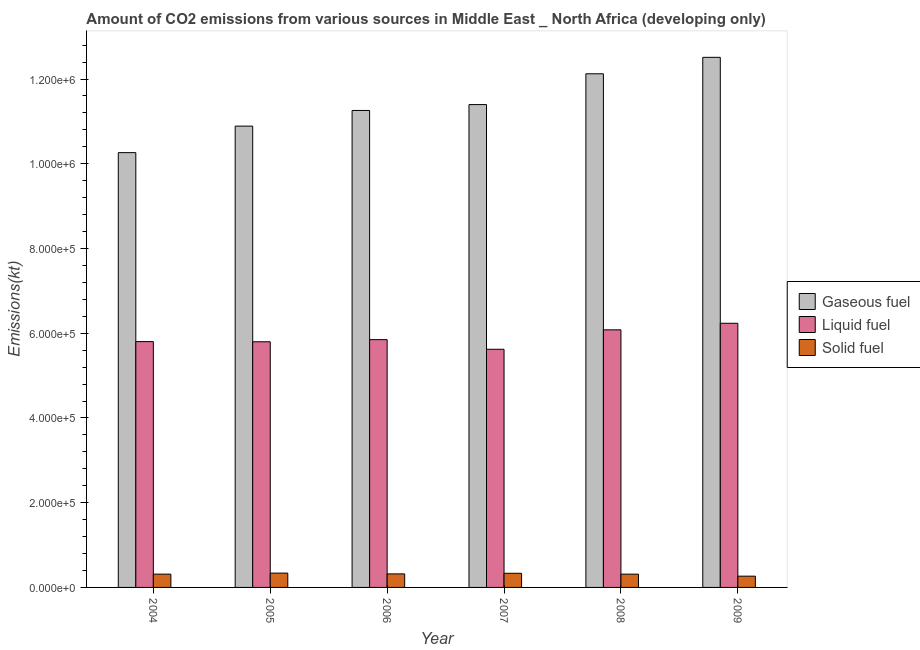How many groups of bars are there?
Provide a succinct answer. 6. Are the number of bars on each tick of the X-axis equal?
Your answer should be compact. Yes. How many bars are there on the 3rd tick from the left?
Ensure brevity in your answer.  3. How many bars are there on the 1st tick from the right?
Provide a short and direct response. 3. What is the label of the 5th group of bars from the left?
Your response must be concise. 2008. What is the amount of co2 emissions from solid fuel in 2009?
Give a very brief answer. 2.66e+04. Across all years, what is the maximum amount of co2 emissions from liquid fuel?
Provide a succinct answer. 6.24e+05. Across all years, what is the minimum amount of co2 emissions from gaseous fuel?
Provide a succinct answer. 1.03e+06. What is the total amount of co2 emissions from solid fuel in the graph?
Provide a short and direct response. 1.88e+05. What is the difference between the amount of co2 emissions from solid fuel in 2004 and that in 2006?
Offer a very short reply. -561.59. What is the difference between the amount of co2 emissions from solid fuel in 2008 and the amount of co2 emissions from liquid fuel in 2005?
Ensure brevity in your answer.  -2484.98. What is the average amount of co2 emissions from liquid fuel per year?
Make the answer very short. 5.90e+05. What is the ratio of the amount of co2 emissions from solid fuel in 2004 to that in 2009?
Offer a terse response. 1.18. Is the difference between the amount of co2 emissions from gaseous fuel in 2004 and 2006 greater than the difference between the amount of co2 emissions from solid fuel in 2004 and 2006?
Give a very brief answer. No. What is the difference between the highest and the second highest amount of co2 emissions from liquid fuel?
Your answer should be very brief. 1.55e+04. What is the difference between the highest and the lowest amount of co2 emissions from gaseous fuel?
Keep it short and to the point. 2.25e+05. In how many years, is the amount of co2 emissions from liquid fuel greater than the average amount of co2 emissions from liquid fuel taken over all years?
Your answer should be very brief. 2. What does the 2nd bar from the left in 2009 represents?
Your answer should be compact. Liquid fuel. What does the 3rd bar from the right in 2006 represents?
Keep it short and to the point. Gaseous fuel. How many bars are there?
Provide a succinct answer. 18. What is the difference between two consecutive major ticks on the Y-axis?
Your response must be concise. 2.00e+05. Does the graph contain any zero values?
Ensure brevity in your answer.  No. Does the graph contain grids?
Keep it short and to the point. No. Where does the legend appear in the graph?
Your response must be concise. Center right. What is the title of the graph?
Give a very brief answer. Amount of CO2 emissions from various sources in Middle East _ North Africa (developing only). Does "Domestic economy" appear as one of the legend labels in the graph?
Your answer should be compact. No. What is the label or title of the X-axis?
Provide a short and direct response. Year. What is the label or title of the Y-axis?
Offer a terse response. Emissions(kt). What is the Emissions(kt) in Gaseous fuel in 2004?
Your response must be concise. 1.03e+06. What is the Emissions(kt) of Liquid fuel in 2004?
Offer a very short reply. 5.80e+05. What is the Emissions(kt) of Solid fuel in 2004?
Offer a terse response. 3.14e+04. What is the Emissions(kt) in Gaseous fuel in 2005?
Your response must be concise. 1.09e+06. What is the Emissions(kt) in Liquid fuel in 2005?
Your response must be concise. 5.80e+05. What is the Emissions(kt) of Solid fuel in 2005?
Offer a terse response. 3.38e+04. What is the Emissions(kt) of Gaseous fuel in 2006?
Provide a succinct answer. 1.13e+06. What is the Emissions(kt) of Liquid fuel in 2006?
Offer a terse response. 5.85e+05. What is the Emissions(kt) in Solid fuel in 2006?
Provide a short and direct response. 3.19e+04. What is the Emissions(kt) in Gaseous fuel in 2007?
Your response must be concise. 1.14e+06. What is the Emissions(kt) of Liquid fuel in 2007?
Ensure brevity in your answer.  5.62e+05. What is the Emissions(kt) of Solid fuel in 2007?
Make the answer very short. 3.34e+04. What is the Emissions(kt) in Gaseous fuel in 2008?
Give a very brief answer. 1.21e+06. What is the Emissions(kt) of Liquid fuel in 2008?
Your answer should be very brief. 6.08e+05. What is the Emissions(kt) in Solid fuel in 2008?
Give a very brief answer. 3.13e+04. What is the Emissions(kt) in Gaseous fuel in 2009?
Offer a terse response. 1.25e+06. What is the Emissions(kt) of Liquid fuel in 2009?
Your answer should be very brief. 6.24e+05. What is the Emissions(kt) of Solid fuel in 2009?
Keep it short and to the point. 2.66e+04. Across all years, what is the maximum Emissions(kt) in Gaseous fuel?
Your answer should be very brief. 1.25e+06. Across all years, what is the maximum Emissions(kt) of Liquid fuel?
Offer a very short reply. 6.24e+05. Across all years, what is the maximum Emissions(kt) of Solid fuel?
Make the answer very short. 3.38e+04. Across all years, what is the minimum Emissions(kt) in Gaseous fuel?
Your answer should be compact. 1.03e+06. Across all years, what is the minimum Emissions(kt) of Liquid fuel?
Your response must be concise. 5.62e+05. Across all years, what is the minimum Emissions(kt) in Solid fuel?
Provide a short and direct response. 2.66e+04. What is the total Emissions(kt) in Gaseous fuel in the graph?
Provide a short and direct response. 6.84e+06. What is the total Emissions(kt) in Liquid fuel in the graph?
Provide a short and direct response. 3.54e+06. What is the total Emissions(kt) of Solid fuel in the graph?
Make the answer very short. 1.88e+05. What is the difference between the Emissions(kt) of Gaseous fuel in 2004 and that in 2005?
Provide a succinct answer. -6.26e+04. What is the difference between the Emissions(kt) of Liquid fuel in 2004 and that in 2005?
Offer a very short reply. 418.04. What is the difference between the Emissions(kt) in Solid fuel in 2004 and that in 2005?
Offer a very short reply. -2440.98. What is the difference between the Emissions(kt) in Gaseous fuel in 2004 and that in 2006?
Keep it short and to the point. -9.95e+04. What is the difference between the Emissions(kt) in Liquid fuel in 2004 and that in 2006?
Make the answer very short. -4649.76. What is the difference between the Emissions(kt) of Solid fuel in 2004 and that in 2006?
Offer a terse response. -561.59. What is the difference between the Emissions(kt) of Gaseous fuel in 2004 and that in 2007?
Make the answer very short. -1.13e+05. What is the difference between the Emissions(kt) in Liquid fuel in 2004 and that in 2007?
Ensure brevity in your answer.  1.81e+04. What is the difference between the Emissions(kt) of Solid fuel in 2004 and that in 2007?
Your response must be concise. -1997.69. What is the difference between the Emissions(kt) in Gaseous fuel in 2004 and that in 2008?
Keep it short and to the point. -1.86e+05. What is the difference between the Emissions(kt) of Liquid fuel in 2004 and that in 2008?
Keep it short and to the point. -2.78e+04. What is the difference between the Emissions(kt) of Solid fuel in 2004 and that in 2008?
Make the answer very short. 44. What is the difference between the Emissions(kt) of Gaseous fuel in 2004 and that in 2009?
Your answer should be compact. -2.25e+05. What is the difference between the Emissions(kt) of Liquid fuel in 2004 and that in 2009?
Make the answer very short. -4.33e+04. What is the difference between the Emissions(kt) of Solid fuel in 2004 and that in 2009?
Offer a very short reply. 4789.2. What is the difference between the Emissions(kt) of Gaseous fuel in 2005 and that in 2006?
Offer a terse response. -3.69e+04. What is the difference between the Emissions(kt) of Liquid fuel in 2005 and that in 2006?
Ensure brevity in your answer.  -5067.79. What is the difference between the Emissions(kt) in Solid fuel in 2005 and that in 2006?
Keep it short and to the point. 1879.4. What is the difference between the Emissions(kt) of Gaseous fuel in 2005 and that in 2007?
Your answer should be compact. -5.08e+04. What is the difference between the Emissions(kt) in Liquid fuel in 2005 and that in 2007?
Make the answer very short. 1.77e+04. What is the difference between the Emissions(kt) of Solid fuel in 2005 and that in 2007?
Make the answer very short. 443.29. What is the difference between the Emissions(kt) of Gaseous fuel in 2005 and that in 2008?
Provide a succinct answer. -1.24e+05. What is the difference between the Emissions(kt) in Liquid fuel in 2005 and that in 2008?
Your answer should be very brief. -2.82e+04. What is the difference between the Emissions(kt) in Solid fuel in 2005 and that in 2008?
Your response must be concise. 2484.98. What is the difference between the Emissions(kt) in Gaseous fuel in 2005 and that in 2009?
Provide a succinct answer. -1.62e+05. What is the difference between the Emissions(kt) in Liquid fuel in 2005 and that in 2009?
Give a very brief answer. -4.37e+04. What is the difference between the Emissions(kt) in Solid fuel in 2005 and that in 2009?
Give a very brief answer. 7230.18. What is the difference between the Emissions(kt) of Gaseous fuel in 2006 and that in 2007?
Keep it short and to the point. -1.39e+04. What is the difference between the Emissions(kt) of Liquid fuel in 2006 and that in 2007?
Provide a succinct answer. 2.28e+04. What is the difference between the Emissions(kt) in Solid fuel in 2006 and that in 2007?
Offer a very short reply. -1436.1. What is the difference between the Emissions(kt) of Gaseous fuel in 2006 and that in 2008?
Keep it short and to the point. -8.66e+04. What is the difference between the Emissions(kt) of Liquid fuel in 2006 and that in 2008?
Offer a very short reply. -2.31e+04. What is the difference between the Emissions(kt) in Solid fuel in 2006 and that in 2008?
Your answer should be very brief. 605.59. What is the difference between the Emissions(kt) of Gaseous fuel in 2006 and that in 2009?
Your answer should be very brief. -1.25e+05. What is the difference between the Emissions(kt) in Liquid fuel in 2006 and that in 2009?
Keep it short and to the point. -3.86e+04. What is the difference between the Emissions(kt) in Solid fuel in 2006 and that in 2009?
Your answer should be compact. 5350.78. What is the difference between the Emissions(kt) in Gaseous fuel in 2007 and that in 2008?
Keep it short and to the point. -7.27e+04. What is the difference between the Emissions(kt) of Liquid fuel in 2007 and that in 2008?
Give a very brief answer. -4.59e+04. What is the difference between the Emissions(kt) of Solid fuel in 2007 and that in 2008?
Give a very brief answer. 2041.69. What is the difference between the Emissions(kt) of Gaseous fuel in 2007 and that in 2009?
Offer a very short reply. -1.12e+05. What is the difference between the Emissions(kt) of Liquid fuel in 2007 and that in 2009?
Provide a succinct answer. -6.14e+04. What is the difference between the Emissions(kt) in Solid fuel in 2007 and that in 2009?
Provide a short and direct response. 6786.89. What is the difference between the Emissions(kt) of Gaseous fuel in 2008 and that in 2009?
Provide a succinct answer. -3.88e+04. What is the difference between the Emissions(kt) of Liquid fuel in 2008 and that in 2009?
Your response must be concise. -1.55e+04. What is the difference between the Emissions(kt) in Solid fuel in 2008 and that in 2009?
Ensure brevity in your answer.  4745.2. What is the difference between the Emissions(kt) of Gaseous fuel in 2004 and the Emissions(kt) of Liquid fuel in 2005?
Your response must be concise. 4.46e+05. What is the difference between the Emissions(kt) in Gaseous fuel in 2004 and the Emissions(kt) in Solid fuel in 2005?
Offer a terse response. 9.92e+05. What is the difference between the Emissions(kt) in Liquid fuel in 2004 and the Emissions(kt) in Solid fuel in 2005?
Make the answer very short. 5.46e+05. What is the difference between the Emissions(kt) of Gaseous fuel in 2004 and the Emissions(kt) of Liquid fuel in 2006?
Give a very brief answer. 4.41e+05. What is the difference between the Emissions(kt) of Gaseous fuel in 2004 and the Emissions(kt) of Solid fuel in 2006?
Offer a very short reply. 9.94e+05. What is the difference between the Emissions(kt) of Liquid fuel in 2004 and the Emissions(kt) of Solid fuel in 2006?
Your response must be concise. 5.48e+05. What is the difference between the Emissions(kt) of Gaseous fuel in 2004 and the Emissions(kt) of Liquid fuel in 2007?
Keep it short and to the point. 4.64e+05. What is the difference between the Emissions(kt) in Gaseous fuel in 2004 and the Emissions(kt) in Solid fuel in 2007?
Ensure brevity in your answer.  9.93e+05. What is the difference between the Emissions(kt) of Liquid fuel in 2004 and the Emissions(kt) of Solid fuel in 2007?
Your answer should be compact. 5.47e+05. What is the difference between the Emissions(kt) in Gaseous fuel in 2004 and the Emissions(kt) in Liquid fuel in 2008?
Provide a short and direct response. 4.18e+05. What is the difference between the Emissions(kt) of Gaseous fuel in 2004 and the Emissions(kt) of Solid fuel in 2008?
Ensure brevity in your answer.  9.95e+05. What is the difference between the Emissions(kt) of Liquid fuel in 2004 and the Emissions(kt) of Solid fuel in 2008?
Your answer should be very brief. 5.49e+05. What is the difference between the Emissions(kt) of Gaseous fuel in 2004 and the Emissions(kt) of Liquid fuel in 2009?
Provide a succinct answer. 4.03e+05. What is the difference between the Emissions(kt) in Gaseous fuel in 2004 and the Emissions(kt) in Solid fuel in 2009?
Make the answer very short. 1.00e+06. What is the difference between the Emissions(kt) of Liquid fuel in 2004 and the Emissions(kt) of Solid fuel in 2009?
Your answer should be very brief. 5.54e+05. What is the difference between the Emissions(kt) in Gaseous fuel in 2005 and the Emissions(kt) in Liquid fuel in 2006?
Give a very brief answer. 5.04e+05. What is the difference between the Emissions(kt) of Gaseous fuel in 2005 and the Emissions(kt) of Solid fuel in 2006?
Your answer should be compact. 1.06e+06. What is the difference between the Emissions(kt) of Liquid fuel in 2005 and the Emissions(kt) of Solid fuel in 2006?
Provide a short and direct response. 5.48e+05. What is the difference between the Emissions(kt) in Gaseous fuel in 2005 and the Emissions(kt) in Liquid fuel in 2007?
Your answer should be compact. 5.27e+05. What is the difference between the Emissions(kt) of Gaseous fuel in 2005 and the Emissions(kt) of Solid fuel in 2007?
Give a very brief answer. 1.06e+06. What is the difference between the Emissions(kt) of Liquid fuel in 2005 and the Emissions(kt) of Solid fuel in 2007?
Your response must be concise. 5.46e+05. What is the difference between the Emissions(kt) in Gaseous fuel in 2005 and the Emissions(kt) in Liquid fuel in 2008?
Provide a short and direct response. 4.81e+05. What is the difference between the Emissions(kt) in Gaseous fuel in 2005 and the Emissions(kt) in Solid fuel in 2008?
Keep it short and to the point. 1.06e+06. What is the difference between the Emissions(kt) in Liquid fuel in 2005 and the Emissions(kt) in Solid fuel in 2008?
Provide a short and direct response. 5.48e+05. What is the difference between the Emissions(kt) in Gaseous fuel in 2005 and the Emissions(kt) in Liquid fuel in 2009?
Provide a short and direct response. 4.65e+05. What is the difference between the Emissions(kt) in Gaseous fuel in 2005 and the Emissions(kt) in Solid fuel in 2009?
Your answer should be compact. 1.06e+06. What is the difference between the Emissions(kt) in Liquid fuel in 2005 and the Emissions(kt) in Solid fuel in 2009?
Offer a very short reply. 5.53e+05. What is the difference between the Emissions(kt) in Gaseous fuel in 2006 and the Emissions(kt) in Liquid fuel in 2007?
Your response must be concise. 5.64e+05. What is the difference between the Emissions(kt) of Gaseous fuel in 2006 and the Emissions(kt) of Solid fuel in 2007?
Keep it short and to the point. 1.09e+06. What is the difference between the Emissions(kt) in Liquid fuel in 2006 and the Emissions(kt) in Solid fuel in 2007?
Make the answer very short. 5.52e+05. What is the difference between the Emissions(kt) in Gaseous fuel in 2006 and the Emissions(kt) in Liquid fuel in 2008?
Make the answer very short. 5.18e+05. What is the difference between the Emissions(kt) in Gaseous fuel in 2006 and the Emissions(kt) in Solid fuel in 2008?
Keep it short and to the point. 1.09e+06. What is the difference between the Emissions(kt) in Liquid fuel in 2006 and the Emissions(kt) in Solid fuel in 2008?
Your answer should be very brief. 5.54e+05. What is the difference between the Emissions(kt) of Gaseous fuel in 2006 and the Emissions(kt) of Liquid fuel in 2009?
Your answer should be very brief. 5.02e+05. What is the difference between the Emissions(kt) in Gaseous fuel in 2006 and the Emissions(kt) in Solid fuel in 2009?
Offer a very short reply. 1.10e+06. What is the difference between the Emissions(kt) of Liquid fuel in 2006 and the Emissions(kt) of Solid fuel in 2009?
Make the answer very short. 5.58e+05. What is the difference between the Emissions(kt) in Gaseous fuel in 2007 and the Emissions(kt) in Liquid fuel in 2008?
Offer a terse response. 5.32e+05. What is the difference between the Emissions(kt) of Gaseous fuel in 2007 and the Emissions(kt) of Solid fuel in 2008?
Provide a succinct answer. 1.11e+06. What is the difference between the Emissions(kt) of Liquid fuel in 2007 and the Emissions(kt) of Solid fuel in 2008?
Ensure brevity in your answer.  5.31e+05. What is the difference between the Emissions(kt) in Gaseous fuel in 2007 and the Emissions(kt) in Liquid fuel in 2009?
Offer a very short reply. 5.16e+05. What is the difference between the Emissions(kt) of Gaseous fuel in 2007 and the Emissions(kt) of Solid fuel in 2009?
Provide a succinct answer. 1.11e+06. What is the difference between the Emissions(kt) of Liquid fuel in 2007 and the Emissions(kt) of Solid fuel in 2009?
Offer a very short reply. 5.36e+05. What is the difference between the Emissions(kt) in Gaseous fuel in 2008 and the Emissions(kt) in Liquid fuel in 2009?
Ensure brevity in your answer.  5.89e+05. What is the difference between the Emissions(kt) of Gaseous fuel in 2008 and the Emissions(kt) of Solid fuel in 2009?
Keep it short and to the point. 1.19e+06. What is the difference between the Emissions(kt) in Liquid fuel in 2008 and the Emissions(kt) in Solid fuel in 2009?
Make the answer very short. 5.81e+05. What is the average Emissions(kt) in Gaseous fuel per year?
Offer a terse response. 1.14e+06. What is the average Emissions(kt) in Liquid fuel per year?
Give a very brief answer. 5.90e+05. What is the average Emissions(kt) in Solid fuel per year?
Offer a terse response. 3.14e+04. In the year 2004, what is the difference between the Emissions(kt) of Gaseous fuel and Emissions(kt) of Liquid fuel?
Make the answer very short. 4.46e+05. In the year 2004, what is the difference between the Emissions(kt) of Gaseous fuel and Emissions(kt) of Solid fuel?
Your answer should be compact. 9.95e+05. In the year 2004, what is the difference between the Emissions(kt) in Liquid fuel and Emissions(kt) in Solid fuel?
Your answer should be compact. 5.49e+05. In the year 2005, what is the difference between the Emissions(kt) of Gaseous fuel and Emissions(kt) of Liquid fuel?
Ensure brevity in your answer.  5.09e+05. In the year 2005, what is the difference between the Emissions(kt) in Gaseous fuel and Emissions(kt) in Solid fuel?
Provide a succinct answer. 1.06e+06. In the year 2005, what is the difference between the Emissions(kt) of Liquid fuel and Emissions(kt) of Solid fuel?
Your answer should be compact. 5.46e+05. In the year 2006, what is the difference between the Emissions(kt) in Gaseous fuel and Emissions(kt) in Liquid fuel?
Your answer should be compact. 5.41e+05. In the year 2006, what is the difference between the Emissions(kt) of Gaseous fuel and Emissions(kt) of Solid fuel?
Offer a very short reply. 1.09e+06. In the year 2006, what is the difference between the Emissions(kt) in Liquid fuel and Emissions(kt) in Solid fuel?
Offer a terse response. 5.53e+05. In the year 2007, what is the difference between the Emissions(kt) in Gaseous fuel and Emissions(kt) in Liquid fuel?
Offer a terse response. 5.78e+05. In the year 2007, what is the difference between the Emissions(kt) of Gaseous fuel and Emissions(kt) of Solid fuel?
Your answer should be very brief. 1.11e+06. In the year 2007, what is the difference between the Emissions(kt) in Liquid fuel and Emissions(kt) in Solid fuel?
Your answer should be very brief. 5.29e+05. In the year 2008, what is the difference between the Emissions(kt) in Gaseous fuel and Emissions(kt) in Liquid fuel?
Give a very brief answer. 6.04e+05. In the year 2008, what is the difference between the Emissions(kt) of Gaseous fuel and Emissions(kt) of Solid fuel?
Make the answer very short. 1.18e+06. In the year 2008, what is the difference between the Emissions(kt) in Liquid fuel and Emissions(kt) in Solid fuel?
Give a very brief answer. 5.77e+05. In the year 2009, what is the difference between the Emissions(kt) of Gaseous fuel and Emissions(kt) of Liquid fuel?
Ensure brevity in your answer.  6.28e+05. In the year 2009, what is the difference between the Emissions(kt) of Gaseous fuel and Emissions(kt) of Solid fuel?
Provide a succinct answer. 1.22e+06. In the year 2009, what is the difference between the Emissions(kt) of Liquid fuel and Emissions(kt) of Solid fuel?
Provide a short and direct response. 5.97e+05. What is the ratio of the Emissions(kt) in Gaseous fuel in 2004 to that in 2005?
Keep it short and to the point. 0.94. What is the ratio of the Emissions(kt) in Liquid fuel in 2004 to that in 2005?
Your response must be concise. 1. What is the ratio of the Emissions(kt) of Solid fuel in 2004 to that in 2005?
Offer a terse response. 0.93. What is the ratio of the Emissions(kt) in Gaseous fuel in 2004 to that in 2006?
Ensure brevity in your answer.  0.91. What is the ratio of the Emissions(kt) of Liquid fuel in 2004 to that in 2006?
Provide a succinct answer. 0.99. What is the ratio of the Emissions(kt) of Solid fuel in 2004 to that in 2006?
Ensure brevity in your answer.  0.98. What is the ratio of the Emissions(kt) of Gaseous fuel in 2004 to that in 2007?
Ensure brevity in your answer.  0.9. What is the ratio of the Emissions(kt) in Liquid fuel in 2004 to that in 2007?
Offer a terse response. 1.03. What is the ratio of the Emissions(kt) in Solid fuel in 2004 to that in 2007?
Offer a very short reply. 0.94. What is the ratio of the Emissions(kt) in Gaseous fuel in 2004 to that in 2008?
Make the answer very short. 0.85. What is the ratio of the Emissions(kt) of Liquid fuel in 2004 to that in 2008?
Offer a very short reply. 0.95. What is the ratio of the Emissions(kt) in Solid fuel in 2004 to that in 2008?
Provide a succinct answer. 1. What is the ratio of the Emissions(kt) of Gaseous fuel in 2004 to that in 2009?
Keep it short and to the point. 0.82. What is the ratio of the Emissions(kt) in Liquid fuel in 2004 to that in 2009?
Ensure brevity in your answer.  0.93. What is the ratio of the Emissions(kt) in Solid fuel in 2004 to that in 2009?
Keep it short and to the point. 1.18. What is the ratio of the Emissions(kt) in Gaseous fuel in 2005 to that in 2006?
Ensure brevity in your answer.  0.97. What is the ratio of the Emissions(kt) in Solid fuel in 2005 to that in 2006?
Give a very brief answer. 1.06. What is the ratio of the Emissions(kt) in Gaseous fuel in 2005 to that in 2007?
Provide a succinct answer. 0.96. What is the ratio of the Emissions(kt) of Liquid fuel in 2005 to that in 2007?
Your answer should be compact. 1.03. What is the ratio of the Emissions(kt) in Solid fuel in 2005 to that in 2007?
Make the answer very short. 1.01. What is the ratio of the Emissions(kt) of Gaseous fuel in 2005 to that in 2008?
Offer a very short reply. 0.9. What is the ratio of the Emissions(kt) of Liquid fuel in 2005 to that in 2008?
Keep it short and to the point. 0.95. What is the ratio of the Emissions(kt) of Solid fuel in 2005 to that in 2008?
Your response must be concise. 1.08. What is the ratio of the Emissions(kt) in Gaseous fuel in 2005 to that in 2009?
Ensure brevity in your answer.  0.87. What is the ratio of the Emissions(kt) in Liquid fuel in 2005 to that in 2009?
Provide a short and direct response. 0.93. What is the ratio of the Emissions(kt) in Solid fuel in 2005 to that in 2009?
Your answer should be compact. 1.27. What is the ratio of the Emissions(kt) of Liquid fuel in 2006 to that in 2007?
Your response must be concise. 1.04. What is the ratio of the Emissions(kt) in Gaseous fuel in 2006 to that in 2008?
Your response must be concise. 0.93. What is the ratio of the Emissions(kt) in Liquid fuel in 2006 to that in 2008?
Your answer should be very brief. 0.96. What is the ratio of the Emissions(kt) of Solid fuel in 2006 to that in 2008?
Provide a succinct answer. 1.02. What is the ratio of the Emissions(kt) of Gaseous fuel in 2006 to that in 2009?
Offer a very short reply. 0.9. What is the ratio of the Emissions(kt) in Liquid fuel in 2006 to that in 2009?
Your answer should be compact. 0.94. What is the ratio of the Emissions(kt) of Solid fuel in 2006 to that in 2009?
Your answer should be very brief. 1.2. What is the ratio of the Emissions(kt) in Gaseous fuel in 2007 to that in 2008?
Provide a succinct answer. 0.94. What is the ratio of the Emissions(kt) in Liquid fuel in 2007 to that in 2008?
Provide a succinct answer. 0.92. What is the ratio of the Emissions(kt) in Solid fuel in 2007 to that in 2008?
Your answer should be compact. 1.07. What is the ratio of the Emissions(kt) in Gaseous fuel in 2007 to that in 2009?
Ensure brevity in your answer.  0.91. What is the ratio of the Emissions(kt) in Liquid fuel in 2007 to that in 2009?
Ensure brevity in your answer.  0.9. What is the ratio of the Emissions(kt) of Solid fuel in 2007 to that in 2009?
Your response must be concise. 1.26. What is the ratio of the Emissions(kt) in Gaseous fuel in 2008 to that in 2009?
Provide a succinct answer. 0.97. What is the ratio of the Emissions(kt) in Liquid fuel in 2008 to that in 2009?
Provide a short and direct response. 0.98. What is the ratio of the Emissions(kt) of Solid fuel in 2008 to that in 2009?
Offer a very short reply. 1.18. What is the difference between the highest and the second highest Emissions(kt) in Gaseous fuel?
Your response must be concise. 3.88e+04. What is the difference between the highest and the second highest Emissions(kt) in Liquid fuel?
Make the answer very short. 1.55e+04. What is the difference between the highest and the second highest Emissions(kt) of Solid fuel?
Provide a short and direct response. 443.29. What is the difference between the highest and the lowest Emissions(kt) of Gaseous fuel?
Make the answer very short. 2.25e+05. What is the difference between the highest and the lowest Emissions(kt) in Liquid fuel?
Your response must be concise. 6.14e+04. What is the difference between the highest and the lowest Emissions(kt) in Solid fuel?
Your answer should be compact. 7230.18. 